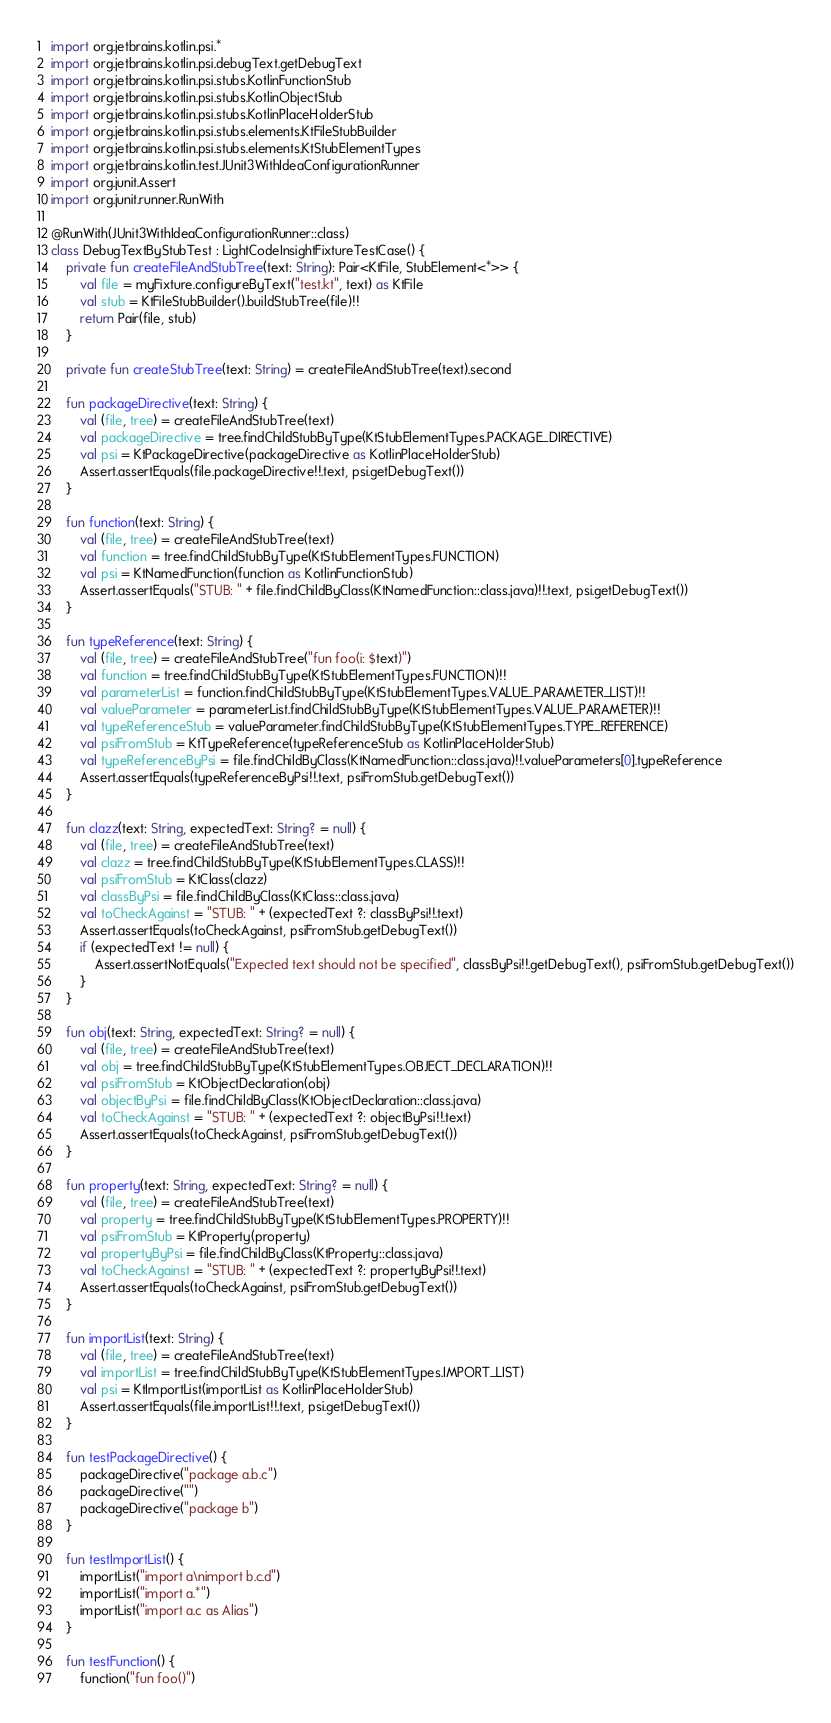Convert code to text. <code><loc_0><loc_0><loc_500><loc_500><_Kotlin_>import org.jetbrains.kotlin.psi.*
import org.jetbrains.kotlin.psi.debugText.getDebugText
import org.jetbrains.kotlin.psi.stubs.KotlinFunctionStub
import org.jetbrains.kotlin.psi.stubs.KotlinObjectStub
import org.jetbrains.kotlin.psi.stubs.KotlinPlaceHolderStub
import org.jetbrains.kotlin.psi.stubs.elements.KtFileStubBuilder
import org.jetbrains.kotlin.psi.stubs.elements.KtStubElementTypes
import org.jetbrains.kotlin.test.JUnit3WithIdeaConfigurationRunner
import org.junit.Assert
import org.junit.runner.RunWith

@RunWith(JUnit3WithIdeaConfigurationRunner::class)
class DebugTextByStubTest : LightCodeInsightFixtureTestCase() {
    private fun createFileAndStubTree(text: String): Pair<KtFile, StubElement<*>> {
        val file = myFixture.configureByText("test.kt", text) as KtFile
        val stub = KtFileStubBuilder().buildStubTree(file)!!
        return Pair(file, stub)
    }

    private fun createStubTree(text: String) = createFileAndStubTree(text).second

    fun packageDirective(text: String) {
        val (file, tree) = createFileAndStubTree(text)
        val packageDirective = tree.findChildStubByType(KtStubElementTypes.PACKAGE_DIRECTIVE)
        val psi = KtPackageDirective(packageDirective as KotlinPlaceHolderStub)
        Assert.assertEquals(file.packageDirective!!.text, psi.getDebugText())
    }

    fun function(text: String) {
        val (file, tree) = createFileAndStubTree(text)
        val function = tree.findChildStubByType(KtStubElementTypes.FUNCTION)
        val psi = KtNamedFunction(function as KotlinFunctionStub)
        Assert.assertEquals("STUB: " + file.findChildByClass(KtNamedFunction::class.java)!!.text, psi.getDebugText())
    }

    fun typeReference(text: String) {
        val (file, tree) = createFileAndStubTree("fun foo(i: $text)")
        val function = tree.findChildStubByType(KtStubElementTypes.FUNCTION)!!
        val parameterList = function.findChildStubByType(KtStubElementTypes.VALUE_PARAMETER_LIST)!!
        val valueParameter = parameterList.findChildStubByType(KtStubElementTypes.VALUE_PARAMETER)!!
        val typeReferenceStub = valueParameter.findChildStubByType(KtStubElementTypes.TYPE_REFERENCE)
        val psiFromStub = KtTypeReference(typeReferenceStub as KotlinPlaceHolderStub)
        val typeReferenceByPsi = file.findChildByClass(KtNamedFunction::class.java)!!.valueParameters[0].typeReference
        Assert.assertEquals(typeReferenceByPsi!!.text, psiFromStub.getDebugText())
    }

    fun clazz(text: String, expectedText: String? = null) {
        val (file, tree) = createFileAndStubTree(text)
        val clazz = tree.findChildStubByType(KtStubElementTypes.CLASS)!!
        val psiFromStub = KtClass(clazz)
        val classByPsi = file.findChildByClass(KtClass::class.java)
        val toCheckAgainst = "STUB: " + (expectedText ?: classByPsi!!.text)
        Assert.assertEquals(toCheckAgainst, psiFromStub.getDebugText())
        if (expectedText != null) {
            Assert.assertNotEquals("Expected text should not be specified", classByPsi!!.getDebugText(), psiFromStub.getDebugText())
        }
    }

    fun obj(text: String, expectedText: String? = null) {
        val (file, tree) = createFileAndStubTree(text)
        val obj = tree.findChildStubByType(KtStubElementTypes.OBJECT_DECLARATION)!!
        val psiFromStub = KtObjectDeclaration(obj)
        val objectByPsi = file.findChildByClass(KtObjectDeclaration::class.java)
        val toCheckAgainst = "STUB: " + (expectedText ?: objectByPsi!!.text)
        Assert.assertEquals(toCheckAgainst, psiFromStub.getDebugText())
    }

    fun property(text: String, expectedText: String? = null) {
        val (file, tree) = createFileAndStubTree(text)
        val property = tree.findChildStubByType(KtStubElementTypes.PROPERTY)!!
        val psiFromStub = KtProperty(property)
        val propertyByPsi = file.findChildByClass(KtProperty::class.java)
        val toCheckAgainst = "STUB: " + (expectedText ?: propertyByPsi!!.text)
        Assert.assertEquals(toCheckAgainst, psiFromStub.getDebugText())
    }

    fun importList(text: String) {
        val (file, tree) = createFileAndStubTree(text)
        val importList = tree.findChildStubByType(KtStubElementTypes.IMPORT_LIST)
        val psi = KtImportList(importList as KotlinPlaceHolderStub)
        Assert.assertEquals(file.importList!!.text, psi.getDebugText())
    }

    fun testPackageDirective() {
        packageDirective("package a.b.c")
        packageDirective("")
        packageDirective("package b")
    }

    fun testImportList() {
        importList("import a\nimport b.c.d")
        importList("import a.*")
        importList("import a.c as Alias")
    }

    fun testFunction() {
        function("fun foo()")</code> 